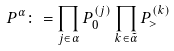<formula> <loc_0><loc_0><loc_500><loc_500>P ^ { \alpha } \colon = \prod _ { j \in \alpha } P _ { 0 } ^ { ( j ) } \prod _ { k \in \tilde { \alpha } } P _ { > } ^ { ( k ) }</formula> 